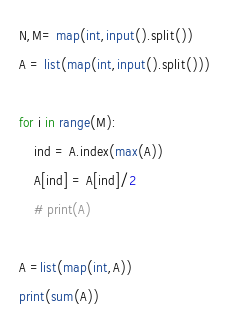<code> <loc_0><loc_0><loc_500><loc_500><_Python_>N,M= map(int,input().split())
A = list(map(int,input().split()))

for i in range(M):
    ind = A.index(max(A))
    A[ind] = A[ind]/2
    # print(A)

A =list(map(int,A))
print(sum(A))</code> 